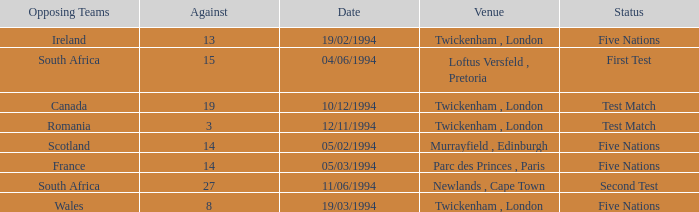How many against have a status of first test? 1.0. 